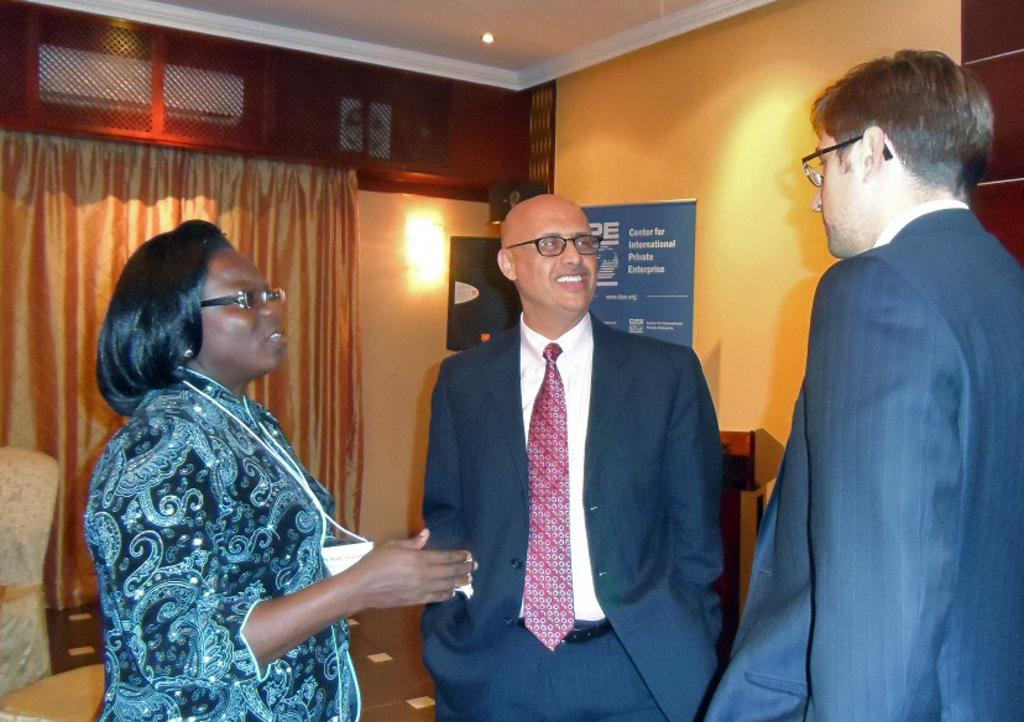How many people are in the image? There are two men and a woman standing in the image, making a total of three individuals. What are the individuals wearing? The individuals are wearing clothes and spectacles. What can be seen on the wall in the image? There is a poster visible on the wall in the image. What type of window treatment is present in the image? There are curtains visible in the image. What is the source of light in the image? There is a light in the image. What type of sweater is the woman wearing in the image? The woman is not wearing a sweater in the image; she is wearing clothes and spectacles. What effect does the light have on the poster in the image? There is no mention of the light having any effect on the poster in the image. 